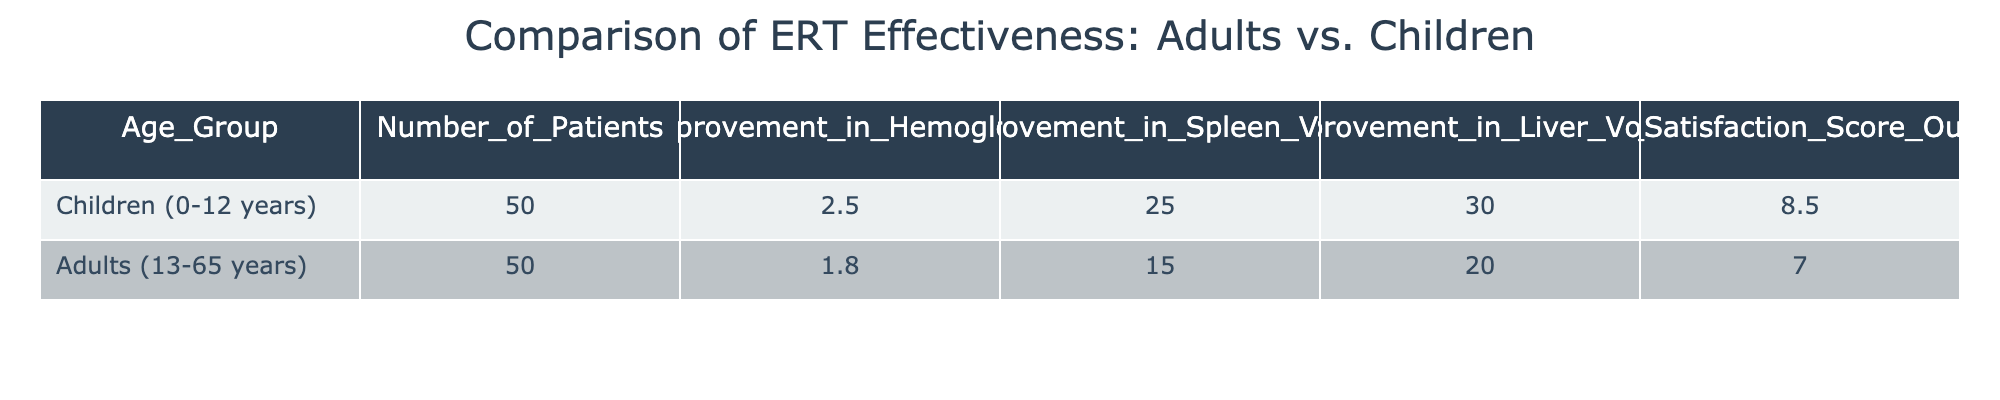What is the mean improvement in hemoglobin for children? The table lists the mean improvement in hemoglobin for children (0-12 years) as 2.5 g/dL.
Answer: 2.5 g/dL What is the mean improvement in liver volume for adults? According to the table, the mean improvement in liver volume for adults (13-65 years) is 20 cm³.
Answer: 20 cm³ Which age group showed a higher patient satisfaction score? The table indicates that children had a patient satisfaction score of 8.5, while adults had a score of 7.0, meaning children had a higher score.
Answer: Children What is the total mean improvement in spleen volume for both age groups combined? The mean improvement in spleen volume for children is 25 cm³ and for adults is 15 cm³. Adding these together gives 25 + 15 = 40 cm³ as the total mean improvement.
Answer: 40 cm³ Is the mean improvement in hemoglobin for adults higher than that for children? The mean improvement in hemoglobin for adults is 1.8 g/dL, which is lower than that for children at 2.5 g/dL. Therefore, the statement is false.
Answer: False What is the difference in mean improvement of spleen volume between children and adults? The mean improvement in spleen volume for children is 25 cm³, and for adults, it is 15 cm³. The difference is calculated as 25 - 15 = 10 cm³.
Answer: 10 cm³ Which group achieved a greater improvement in both spleen and liver volume? In the table, children achieved a mean improvement of 25 cm³ in spleen volume and 30 cm³ in liver volume, while adults achieved 15 cm³ and 20 cm³, respectively. Thus, children had greater improvement in both.
Answer: Children What is the average patient satisfaction score across both age groups? The patient satisfaction score for children is 8.5 and for adults, it is 7.0. To find the average: (8.5 + 7.0) / 2 = 7.75.
Answer: 7.75 